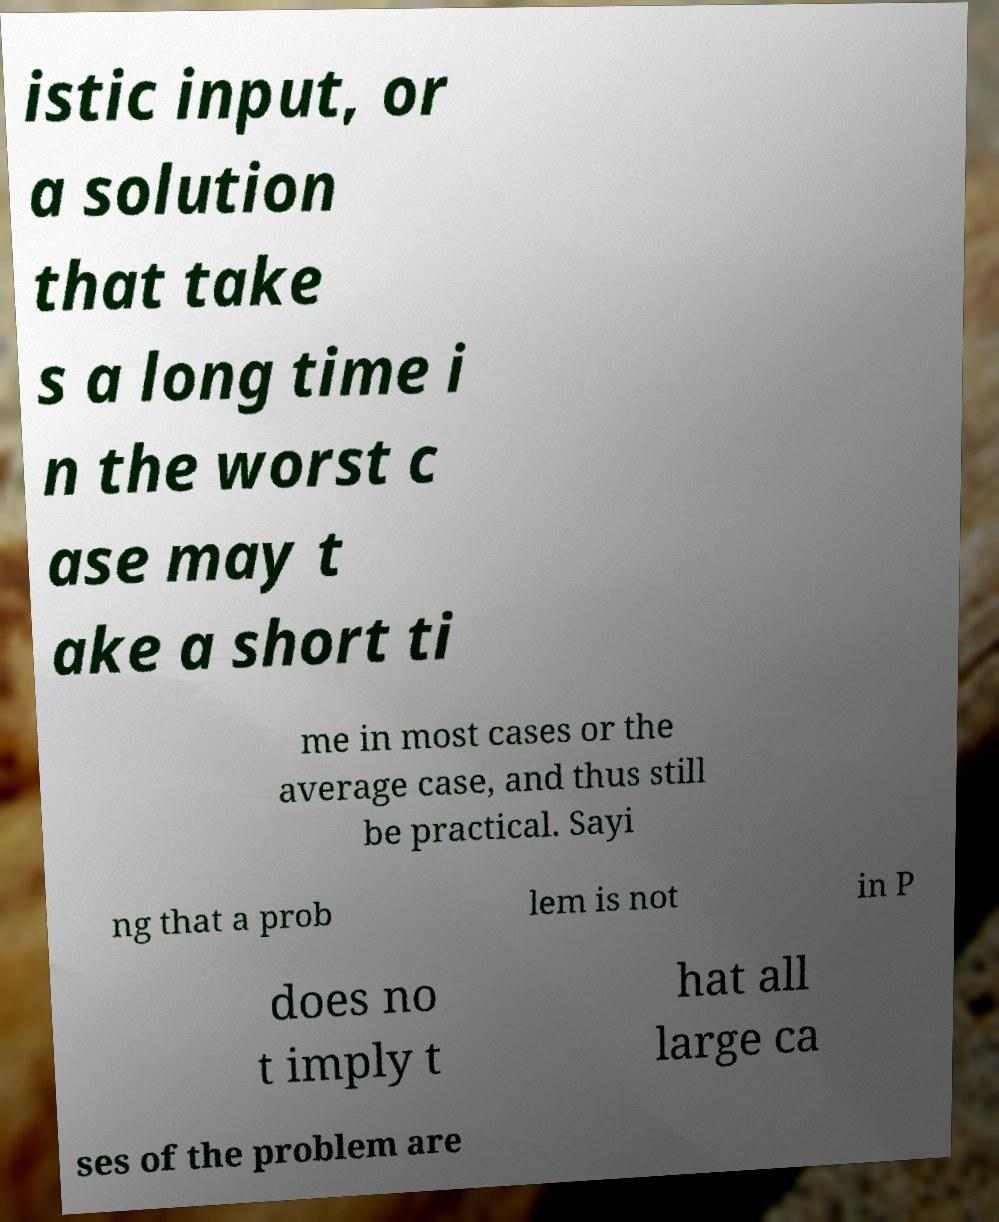Can you read and provide the text displayed in the image?This photo seems to have some interesting text. Can you extract and type it out for me? istic input, or a solution that take s a long time i n the worst c ase may t ake a short ti me in most cases or the average case, and thus still be practical. Sayi ng that a prob lem is not in P does no t imply t hat all large ca ses of the problem are 